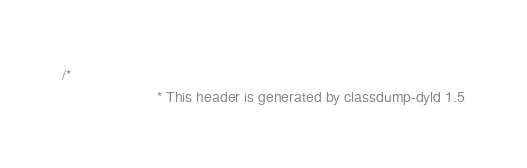<code> <loc_0><loc_0><loc_500><loc_500><_C_>/*
                       * This header is generated by classdump-dyld 1.5</code> 